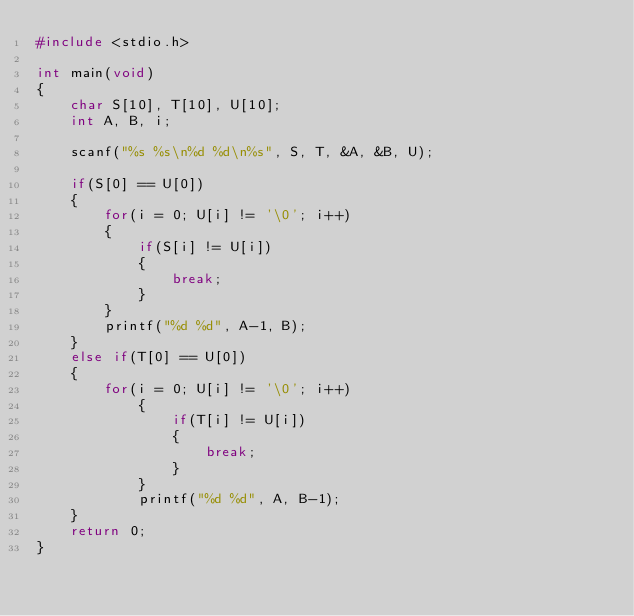<code> <loc_0><loc_0><loc_500><loc_500><_C_>#include <stdio.h>

int main(void)
{
	char S[10], T[10], U[10];
	int A, B, i;

	scanf("%s %s\n%d %d\n%s", S, T, &A, &B, U);

	if(S[0] == U[0])
	{
		for(i = 0; U[i] != '\0'; i++)
		{
			if(S[i] != U[i])
			{
				break;
			}
		}
		printf("%d %d", A-1, B);
	}
	else if(T[0] == U[0])
	{
		for(i = 0; U[i] != '\0'; i++)
			{
				if(T[i] != U[i])
				{
					break;
				}
			}
			printf("%d %d", A, B-1);
	}
	return 0;
}
</code> 